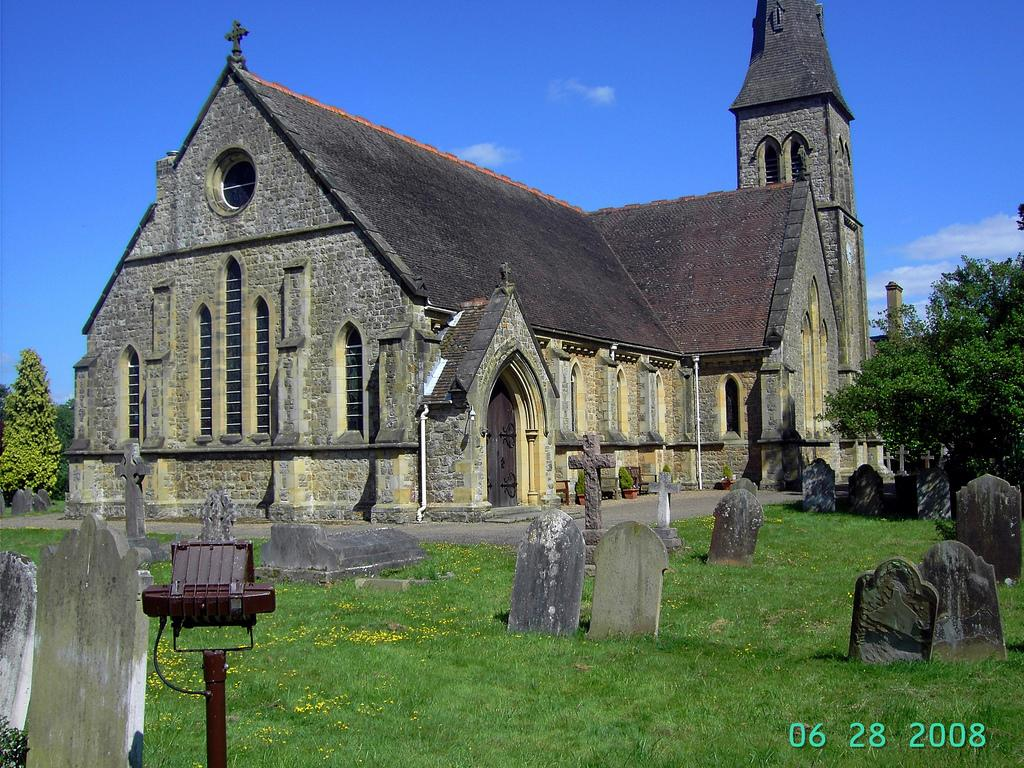What type of location is depicted in the image? There is a graveyard in the image. What is covering the ground in the graveyard? The ground in the graveyard is covered with grass. What can be seen in the background of the image? There are trees visible in the background of the image. What is the condition of the sky in the image? The sky is clear and visible at the top of the image. How many cactus plants are present in the image? There are no cactus plants present in the image; the ground is covered with grass. What type of bulb is used to illuminate the graveyard in the image? There is no mention of any bulbs or lighting in the image; it only shows the graveyard, grass, trees, and the clear sky. 